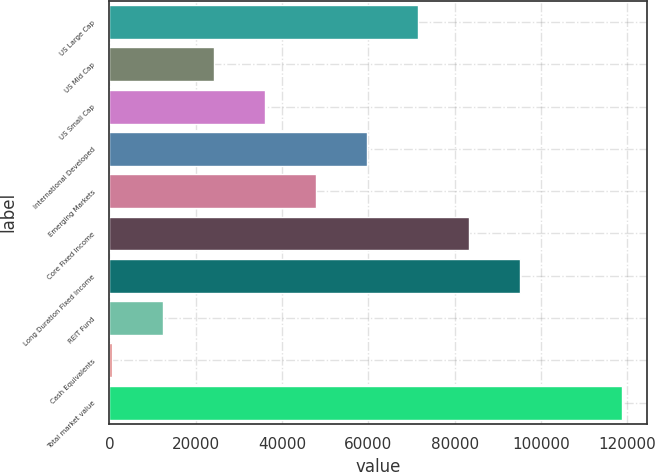Convert chart to OTSL. <chart><loc_0><loc_0><loc_500><loc_500><bar_chart><fcel>US Large Cap<fcel>US Mid Cap<fcel>US Small Cap<fcel>International Developed<fcel>Emerging Markets<fcel>Core Fixed Income<fcel>Long Duration Fixed Income<fcel>REIT Fund<fcel>Cash Equivalents<fcel>Total market value<nl><fcel>71408.2<fcel>24149.4<fcel>35964.1<fcel>59593.5<fcel>47778.8<fcel>83222.9<fcel>95037.6<fcel>12334.7<fcel>520<fcel>118667<nl></chart> 